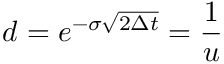<formula> <loc_0><loc_0><loc_500><loc_500>d = e ^ { - \sigma { \sqrt { 2 \Delta t } } } = { \frac { 1 } { u } }</formula> 